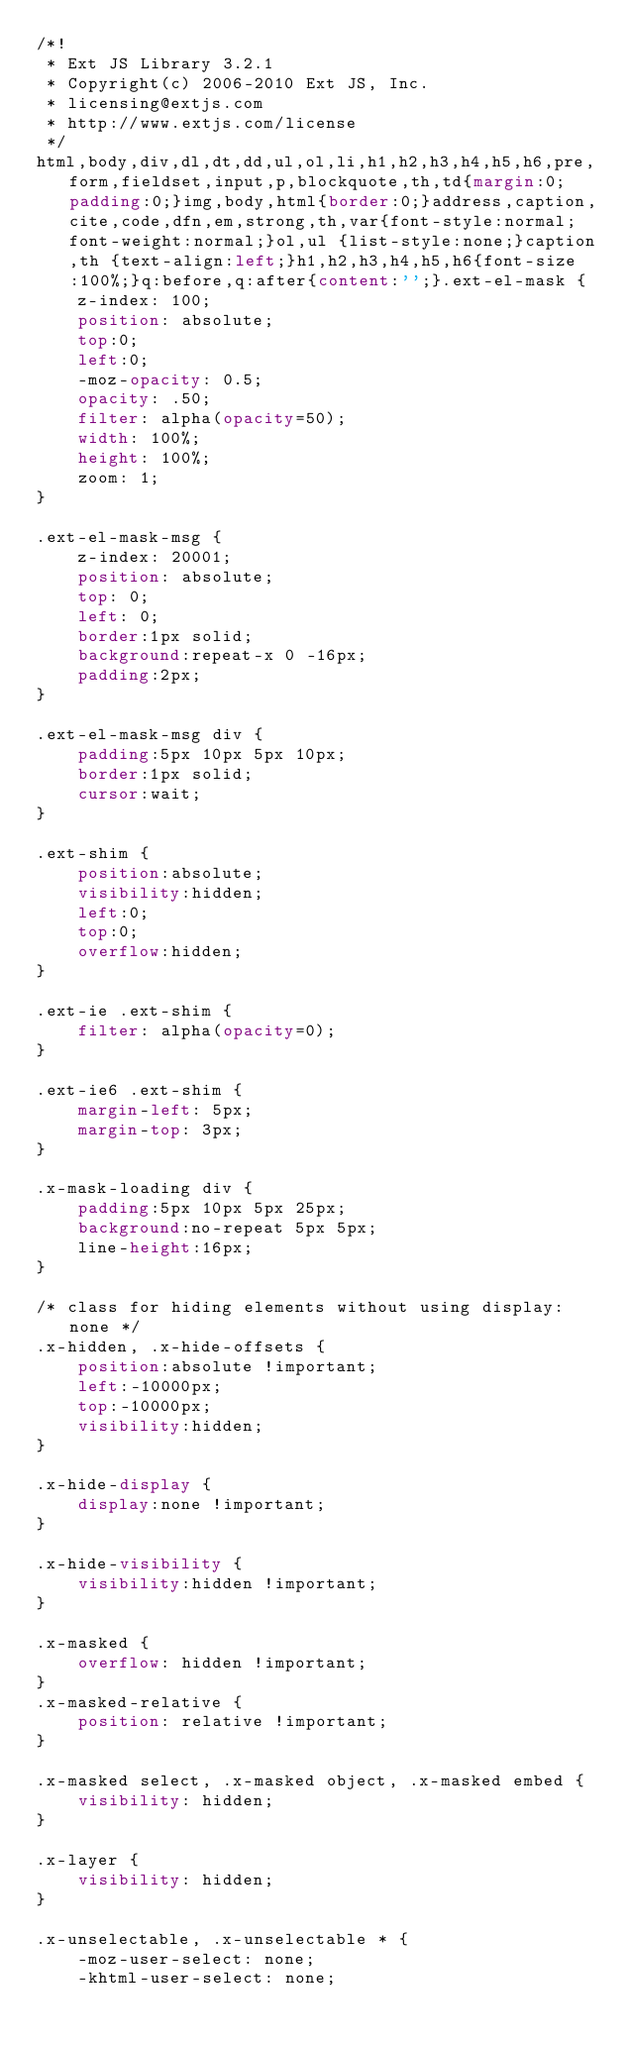<code> <loc_0><loc_0><loc_500><loc_500><_CSS_>/*!
 * Ext JS Library 3.2.1
 * Copyright(c) 2006-2010 Ext JS, Inc.
 * licensing@extjs.com
 * http://www.extjs.com/license
 */
html,body,div,dl,dt,dd,ul,ol,li,h1,h2,h3,h4,h5,h6,pre,form,fieldset,input,p,blockquote,th,td{margin:0;padding:0;}img,body,html{border:0;}address,caption,cite,code,dfn,em,strong,th,var{font-style:normal;font-weight:normal;}ol,ul {list-style:none;}caption,th {text-align:left;}h1,h2,h3,h4,h5,h6{font-size:100%;}q:before,q:after{content:'';}.ext-el-mask {
    z-index: 100;
    position: absolute;
    top:0;
    left:0;
    -moz-opacity: 0.5;
    opacity: .50;
    filter: alpha(opacity=50);
    width: 100%;
    height: 100%;
    zoom: 1;
}

.ext-el-mask-msg {
    z-index: 20001;
    position: absolute;
    top: 0;
    left: 0;
    border:1px solid;
    background:repeat-x 0 -16px;
    padding:2px;
}

.ext-el-mask-msg div {
    padding:5px 10px 5px 10px;
    border:1px solid;
    cursor:wait;
}

.ext-shim {
    position:absolute;
    visibility:hidden;
    left:0;
    top:0;
    overflow:hidden;
}

.ext-ie .ext-shim {
    filter: alpha(opacity=0);
}

.ext-ie6 .ext-shim {
    margin-left: 5px;
    margin-top: 3px;
}

.x-mask-loading div {
    padding:5px 10px 5px 25px;
    background:no-repeat 5px 5px;
    line-height:16px;
}

/* class for hiding elements without using display:none */
.x-hidden, .x-hide-offsets {
    position:absolute !important;
    left:-10000px;
    top:-10000px;
    visibility:hidden;
}

.x-hide-display {
    display:none !important;
}

.x-hide-visibility {
    visibility:hidden !important;
}

.x-masked {
    overflow: hidden !important;
}
.x-masked-relative {
    position: relative !important;
}

.x-masked select, .x-masked object, .x-masked embed {
    visibility: hidden;
}

.x-layer {
    visibility: hidden;
}

.x-unselectable, .x-unselectable * {
    -moz-user-select: none;
    -khtml-user-select: none;</code> 